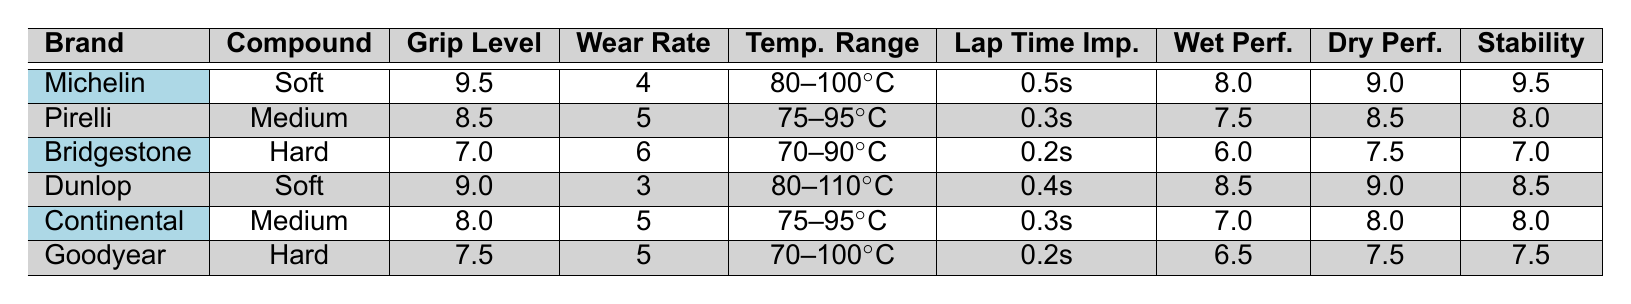What is the grip level of Michelin tires? The table lists the grip level for Michelin tires as 9.5.
Answer: 9.5 Which tire brand has the highest stability rating? The stability ratings for the brands are: Michelin 9.5, Pirelli 8.0, Bridgestone 7.0, Dunlop 8.5, Continental 8.0, and Goodyear 7.5. Michelin has the highest stability rating.
Answer: Michelin What is the wear rate of Dunlop tires? The table indicates that the wear rate for Dunlop tires is 3.
Answer: 3 Which tire brand has the best wet performance? The wet performance ratings are: Michelin 8.0, Pirelli 7.5, Bridgestone 6.0, Dunlop 8.5, Continental 7.0, and Goodyear 6.5. Dunlop has the best wet performance with a rating of 8.5.
Answer: Dunlop What is the average grip level of all the listed tire brands? The grip levels are: 9.5, 8.5, 7.0, 9.0, 8.0, and 7.5. The sum of these values is 9.5 + 8.5 + 7.0 + 9.0 + 8.0 + 7.5 = 49.5. Divided by 6 brands gives an average of 49.5 / 6 = 8.25.
Answer: 8.25 Is the wear rate of Pirelli tires lower than that of Goodyear tires? The wear rates are: Pirelli 5 and Goodyear 5. Since both rates are equal, the statement is false.
Answer: No What is the lap time improvement for the brand with the highest grip level? The highest grip level is 9.5 for Michelin, which has a lap time improvement of 0.5 seconds.
Answer: 0.5 seconds Which tire compound has the best dry performance rating? The dry performance ratings are: Michelin 9.0, Pirelli 8.5, Bridgestone 7.5, Dunlop 9.0, Continental 8.0, and Goodyear 7.5. Michelin and Dunlop both have the highest dry performance rating of 9.0.
Answer: Michelin and Dunlop If temperature range for Dunlop tires is 80-110°C, what is the temperature range for Continental tires? The table shows that the temperature range for Continental tires is 75-95°C.
Answer: 75-95°C How much better is the wet performance of Dunlop tires compared to Bridgestone? Dunlop has a wet performance of 8.5 and Bridgestone has 6.0. The difference is 8.5 - 6.0 = 2.5, indicating that Dunlop outperforms Bridgestone by 2.5.
Answer: 2.5 